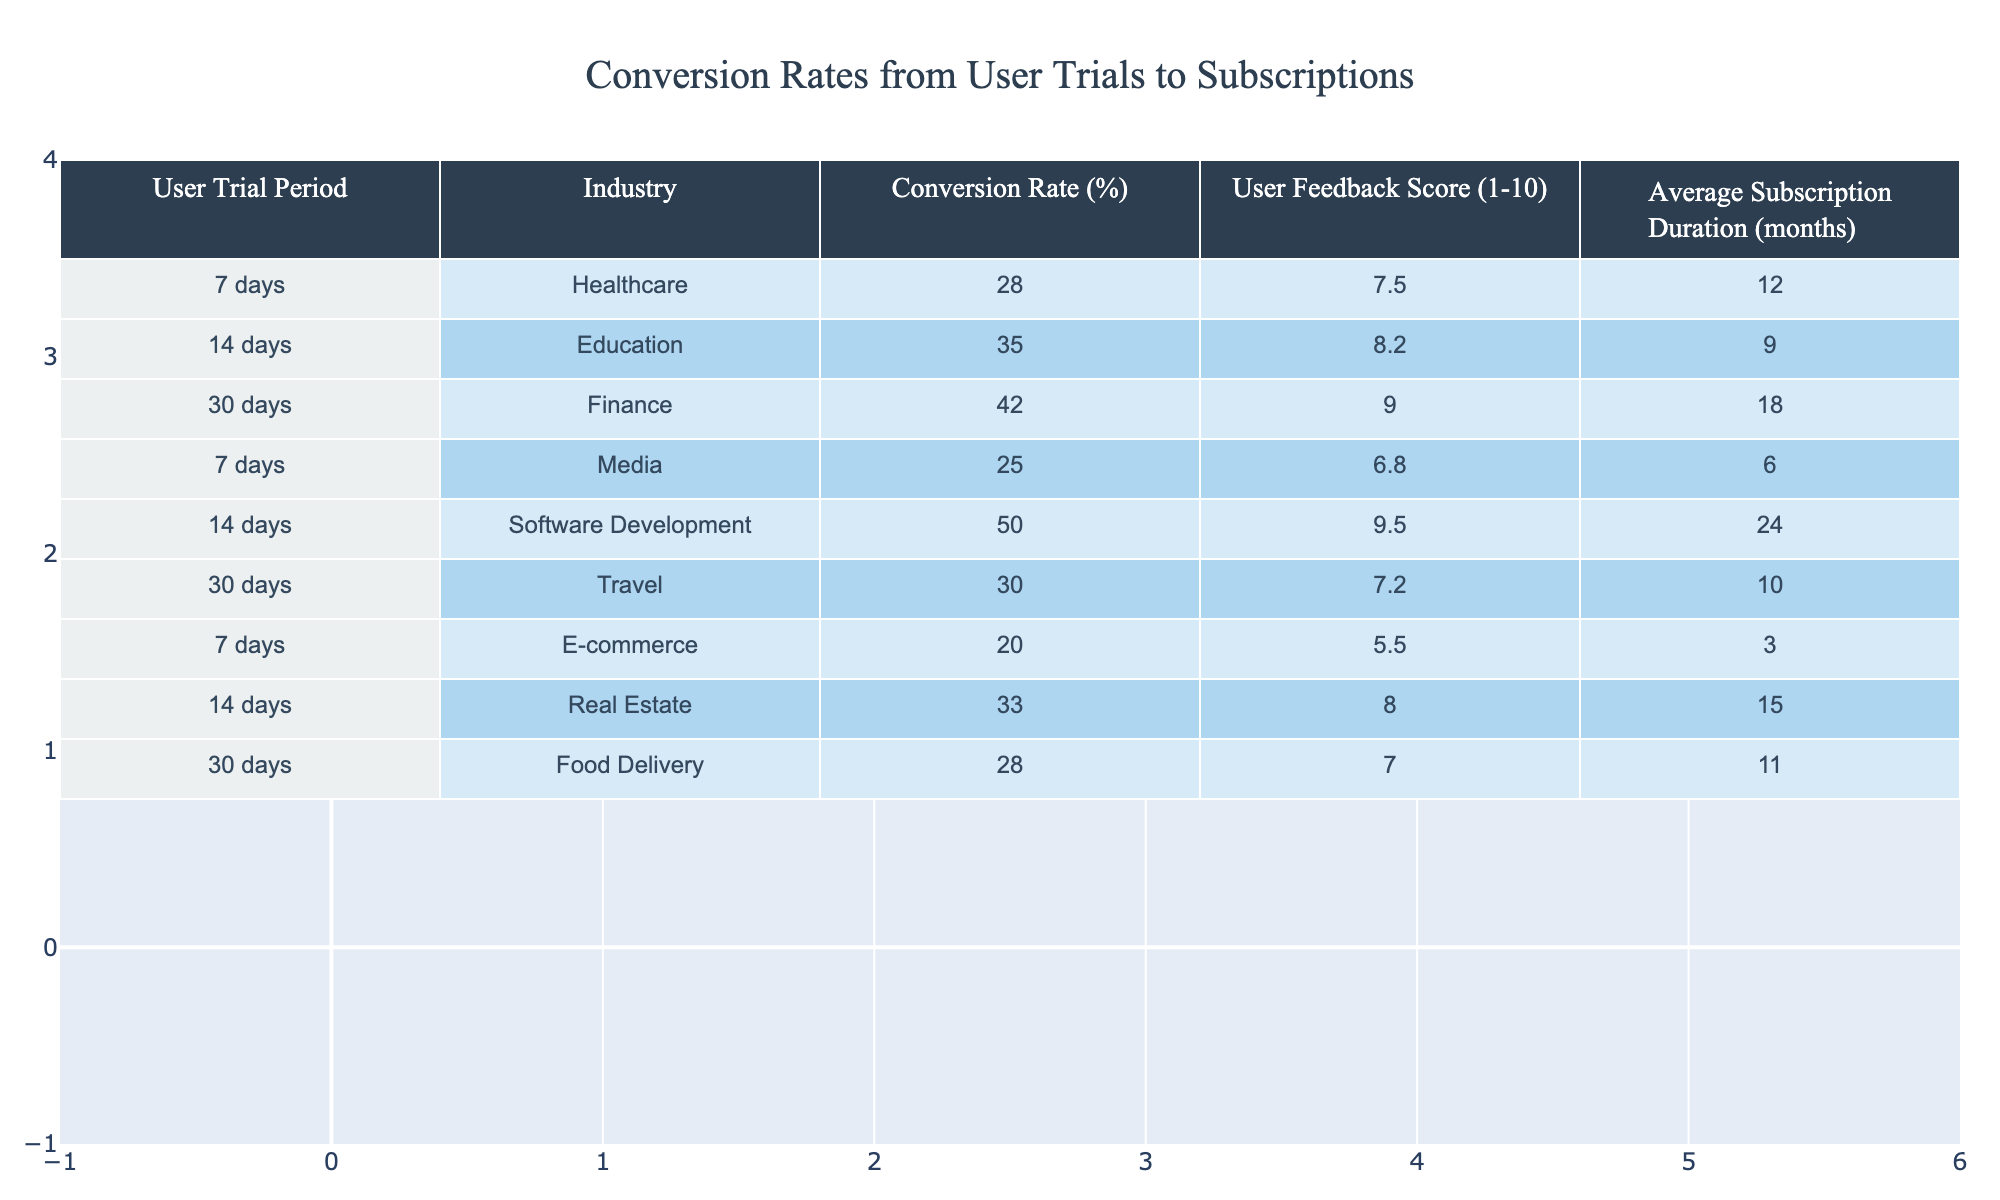What is the highest conversion rate among the industries listed? The table shows the conversion rates for each industry. By looking through the values, Finance has the highest conversion rate at 42%.
Answer: 42% What is the average user feedback score across all industries? To find the average user feedback score, sum all the user feedback scores: (7.5 + 8.2 + 9.0 + 6.8 + 9.5 + 7.2 + 5.5 + 8.0 + 7.0) = 69.7. Then divide by the number of industries (9): 69.7 / 9 ≈ 7.74.
Answer: 7.74 Is the conversion rate for the Media industry higher than that for E-commerce? The conversion rate for Media is 25% and for E-commerce is 20%. Since 25% is greater than 20%, the statement is true.
Answer: Yes Which user trial period has the lowest average subscription duration? The table indicates the average subscription duration for each industry. The lowest value is for E-commerce with 3 months.
Answer: 3 months Which industry has the highest user feedback score and what is that score? By reviewing the scores, Software Development has the highest score at 9.5.
Answer: 9.5 What is the total conversion rate from the User Trials of Healthcare and Education? The conversion rates for Healthcare and Education are 28% and 35%, respectively. Adding these together gives 28 + 35 = 63%.
Answer: 63% Are there any industries with a user feedback score of 10? By checking the user feedback scores in the table, there are no scores recorded as 10. Therefore, the answer is false.
Answer: No If you consider the industries with a user trial period of 30 days only, what is the average conversion rate? The industries with a 30-day trial are Finance, Travel, and Food Delivery with conversion rates of 42%, 30%, and 28%, respectively. The average is calculated by (42 + 30 + 28) / 3 = 100 / 3 = 33.33%.
Answer: 33.33% What is the difference in user feedback scores between the highest and lowest industries? The highest score is for Software Development (9.5) and lowest is for E-commerce (5.5). The difference is 9.5 - 5.5 = 4.
Answer: 4 